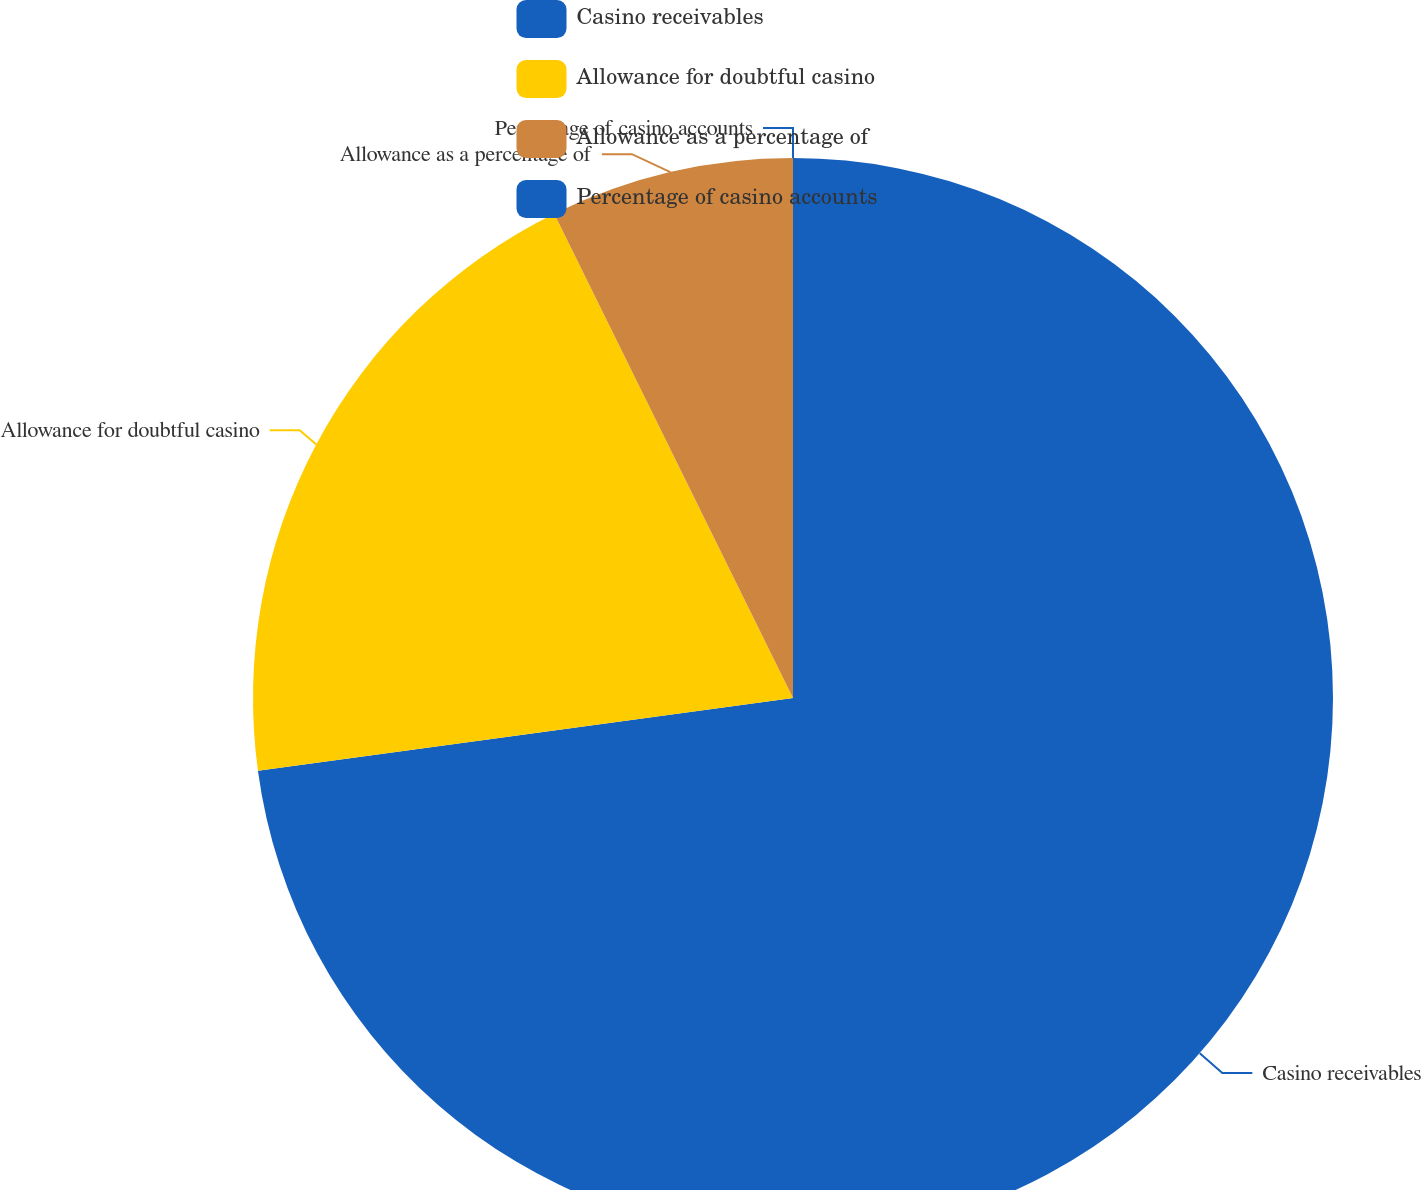Convert chart to OTSL. <chart><loc_0><loc_0><loc_500><loc_500><pie_chart><fcel>Casino receivables<fcel>Allowance for doubtful casino<fcel>Allowance as a percentage of<fcel>Percentage of casino accounts<nl><fcel>72.85%<fcel>19.86%<fcel>7.29%<fcel>0.0%<nl></chart> 